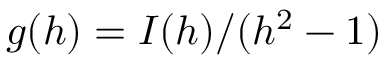Convert formula to latex. <formula><loc_0><loc_0><loc_500><loc_500>g ( h ) = I ( h ) / ( h ^ { 2 } - 1 )</formula> 